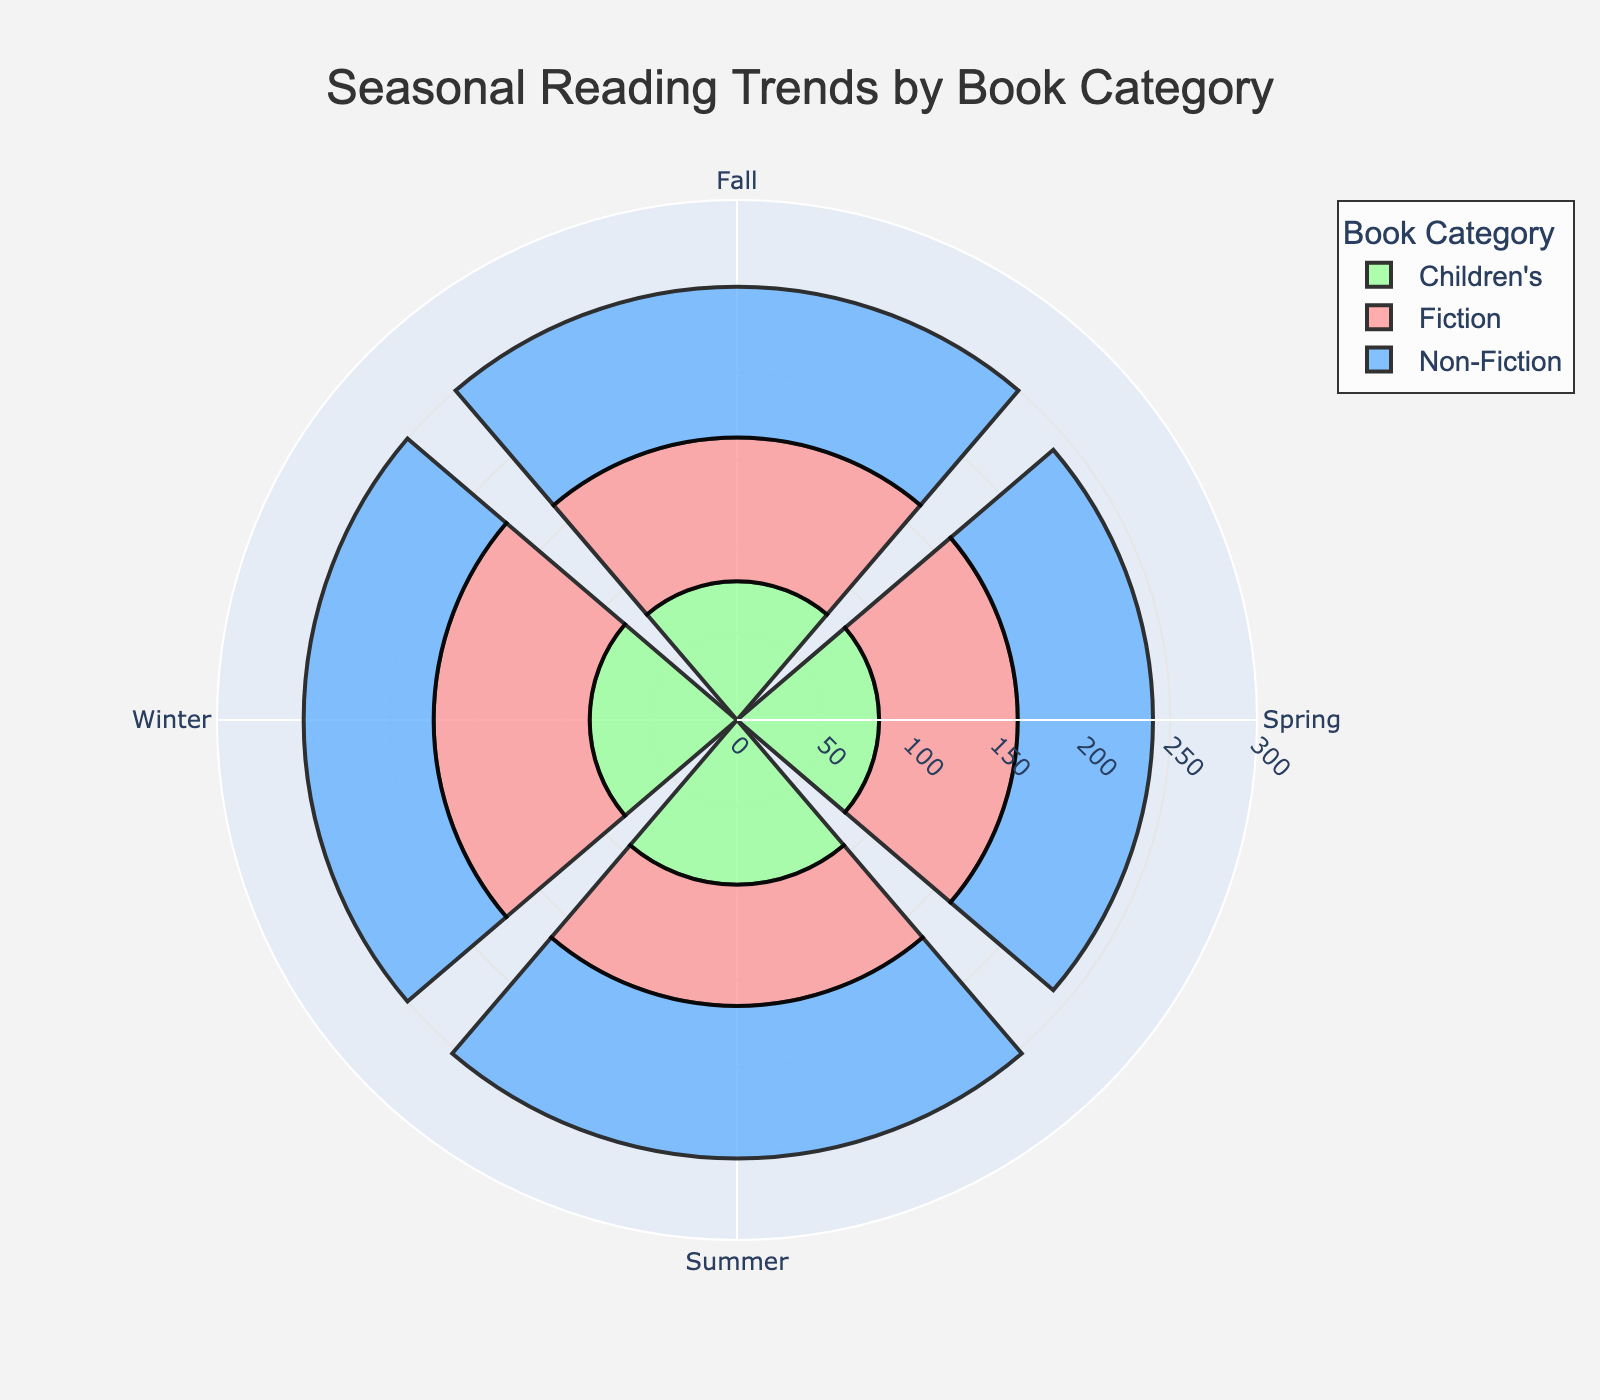What is the title of the chart? The title of the chart is prominently displayed at the top of the figure. It provides a summary of what the chart represents.
Answer: Seasonal Reading Trends by Book Category Which season has the highest popularity score for Children's books? Look at the bars with the color representing Children's books in each season and identify the tallest one.
Answer: Summer What is the popularity score for Fiction books in Winter? Locate the Fiction category in Winter and read the corresponding popularity score.
Answer: 90 Compare the popularity scores of Non-Fiction books in Fall and Spring. Which is higher? Identify the bars for Non-Fiction in Fall and Spring and compare the heights or read the scores directly.
Answer: Fall Which category has the most consistent popularity score across all seasons? Check each category and observe the variation in the heights of their corresponding bars across seasons.
Answer: Children's Calculate the total popularity score for Fiction books across all seasons. Add the popularity scores for Fiction books in Winter, Spring, Summer, and Fall. (90 + 80 + 70 + 83)
Answer: 323 Is the popularity score higher for Non-Fiction or Children's books in Winter? Compare the scores for Non-Fiction and Children's books in Winter by observing the respective bar heights.
Answer: Children’s Which season shows the most significant difference between the popularity scores of Fiction and Non-Fiction books? Calculate the difference between these two categories for each season and find the largest value.
Answer: Winter What is the combined popularity score for all categories in Summer? Add the popularity scores for all categories in Summer. (70 + 88 + 95)
Answer: 253 Are there any categories where the popularity score decreases in consecutive seasons? Examine each category’s trend across seasons and note any decreases between two consecutive bars.
Answer: Fiction (Spring to Summer) 